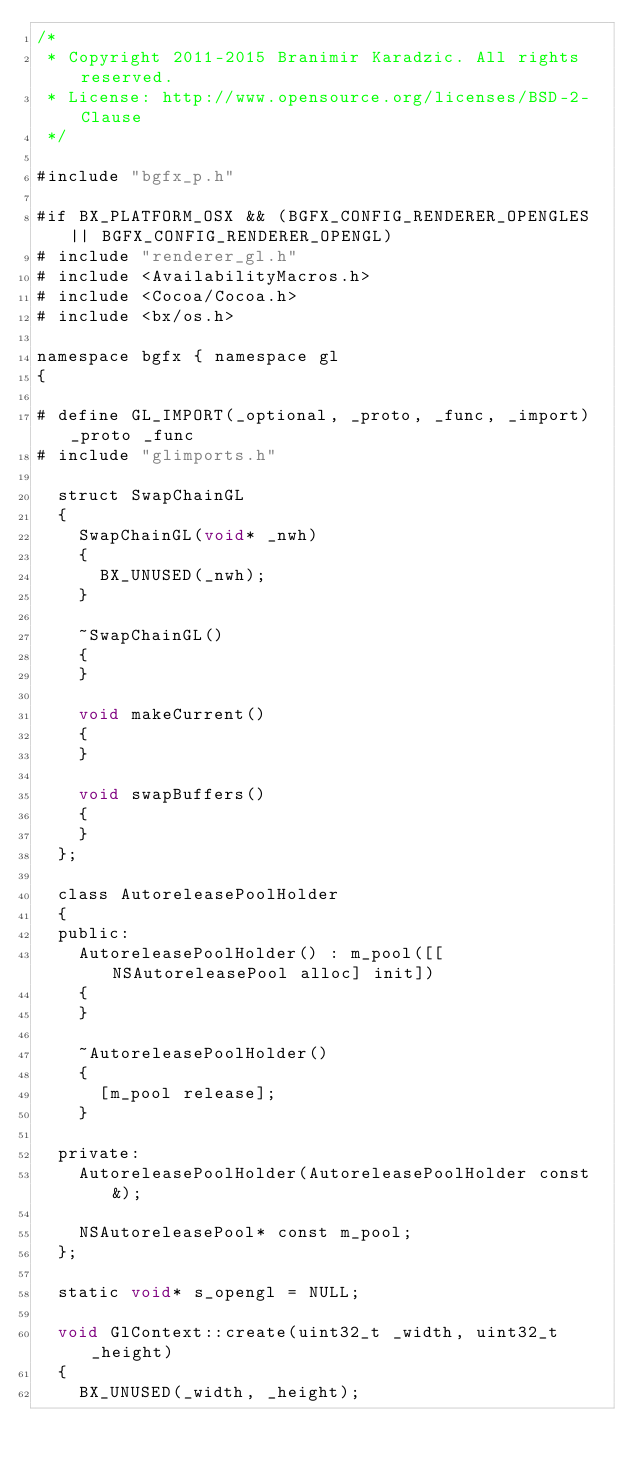Convert code to text. <code><loc_0><loc_0><loc_500><loc_500><_ObjectiveC_>/*
 * Copyright 2011-2015 Branimir Karadzic. All rights reserved.
 * License: http://www.opensource.org/licenses/BSD-2-Clause
 */

#include "bgfx_p.h"

#if BX_PLATFORM_OSX && (BGFX_CONFIG_RENDERER_OPENGLES || BGFX_CONFIG_RENDERER_OPENGL)
#	include "renderer_gl.h"
#	include <AvailabilityMacros.h>
#	include <Cocoa/Cocoa.h>
#	include <bx/os.h>

namespace bgfx { namespace gl
{

#	define GL_IMPORT(_optional, _proto, _func, _import) _proto _func
#	include "glimports.h"

	struct SwapChainGL
	{
		SwapChainGL(void* _nwh)
		{
			BX_UNUSED(_nwh);
		}

		~SwapChainGL()
		{
		}

		void makeCurrent()
		{
		}

		void swapBuffers()
		{
		}
	};

	class AutoreleasePoolHolder
	{
	public:
		AutoreleasePoolHolder() : m_pool([[NSAutoreleasePool alloc] init])
		{
		}

		~AutoreleasePoolHolder()
		{
			[m_pool release];
		}

	private:
		AutoreleasePoolHolder(AutoreleasePoolHolder const&);

		NSAutoreleasePool* const m_pool;
	};

	static void* s_opengl = NULL;

	void GlContext::create(uint32_t _width, uint32_t _height)
	{
		BX_UNUSED(_width, _height);
</code> 